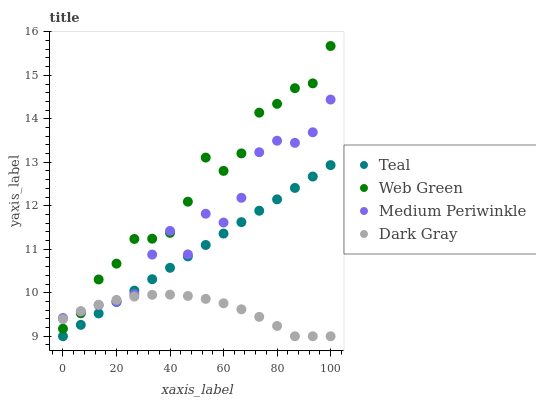Does Dark Gray have the minimum area under the curve?
Answer yes or no. Yes. Does Web Green have the maximum area under the curve?
Answer yes or no. Yes. Does Medium Periwinkle have the minimum area under the curve?
Answer yes or no. No. Does Medium Periwinkle have the maximum area under the curve?
Answer yes or no. No. Is Teal the smoothest?
Answer yes or no. Yes. Is Medium Periwinkle the roughest?
Answer yes or no. Yes. Is Web Green the smoothest?
Answer yes or no. No. Is Web Green the roughest?
Answer yes or no. No. Does Dark Gray have the lowest value?
Answer yes or no. Yes. Does Web Green have the lowest value?
Answer yes or no. No. Does Web Green have the highest value?
Answer yes or no. Yes. Does Medium Periwinkle have the highest value?
Answer yes or no. No. Is Teal less than Web Green?
Answer yes or no. Yes. Is Web Green greater than Teal?
Answer yes or no. Yes. Does Dark Gray intersect Medium Periwinkle?
Answer yes or no. Yes. Is Dark Gray less than Medium Periwinkle?
Answer yes or no. No. Is Dark Gray greater than Medium Periwinkle?
Answer yes or no. No. Does Teal intersect Web Green?
Answer yes or no. No. 